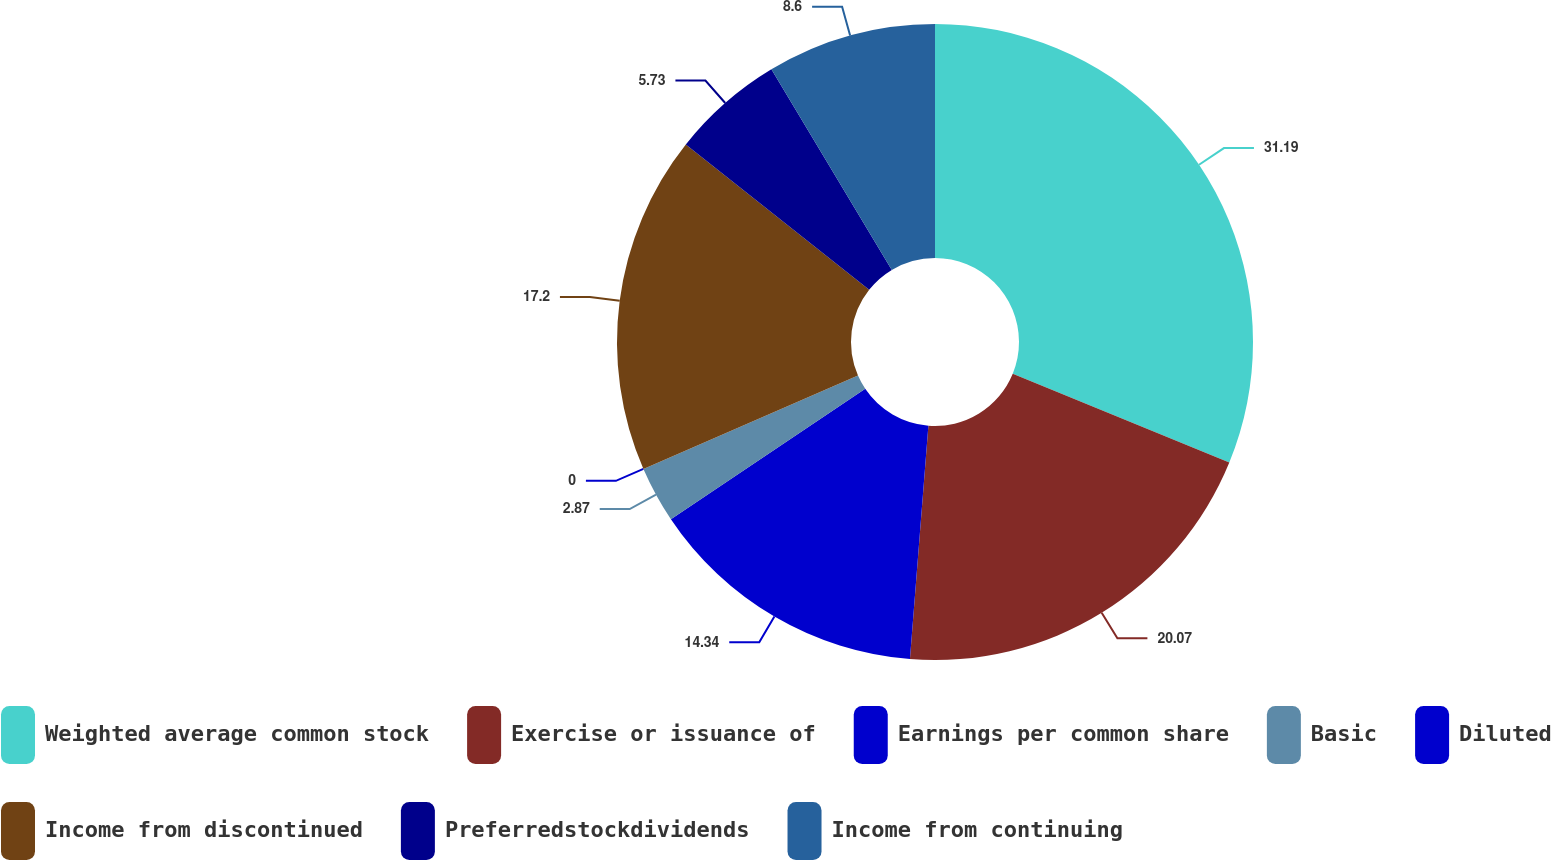Convert chart. <chart><loc_0><loc_0><loc_500><loc_500><pie_chart><fcel>Weighted average common stock<fcel>Exercise or issuance of<fcel>Earnings per common share<fcel>Basic<fcel>Diluted<fcel>Income from discontinued<fcel>Preferredstockdividends<fcel>Income from continuing<nl><fcel>31.18%<fcel>20.07%<fcel>14.34%<fcel>2.87%<fcel>0.0%<fcel>17.2%<fcel>5.73%<fcel>8.6%<nl></chart> 